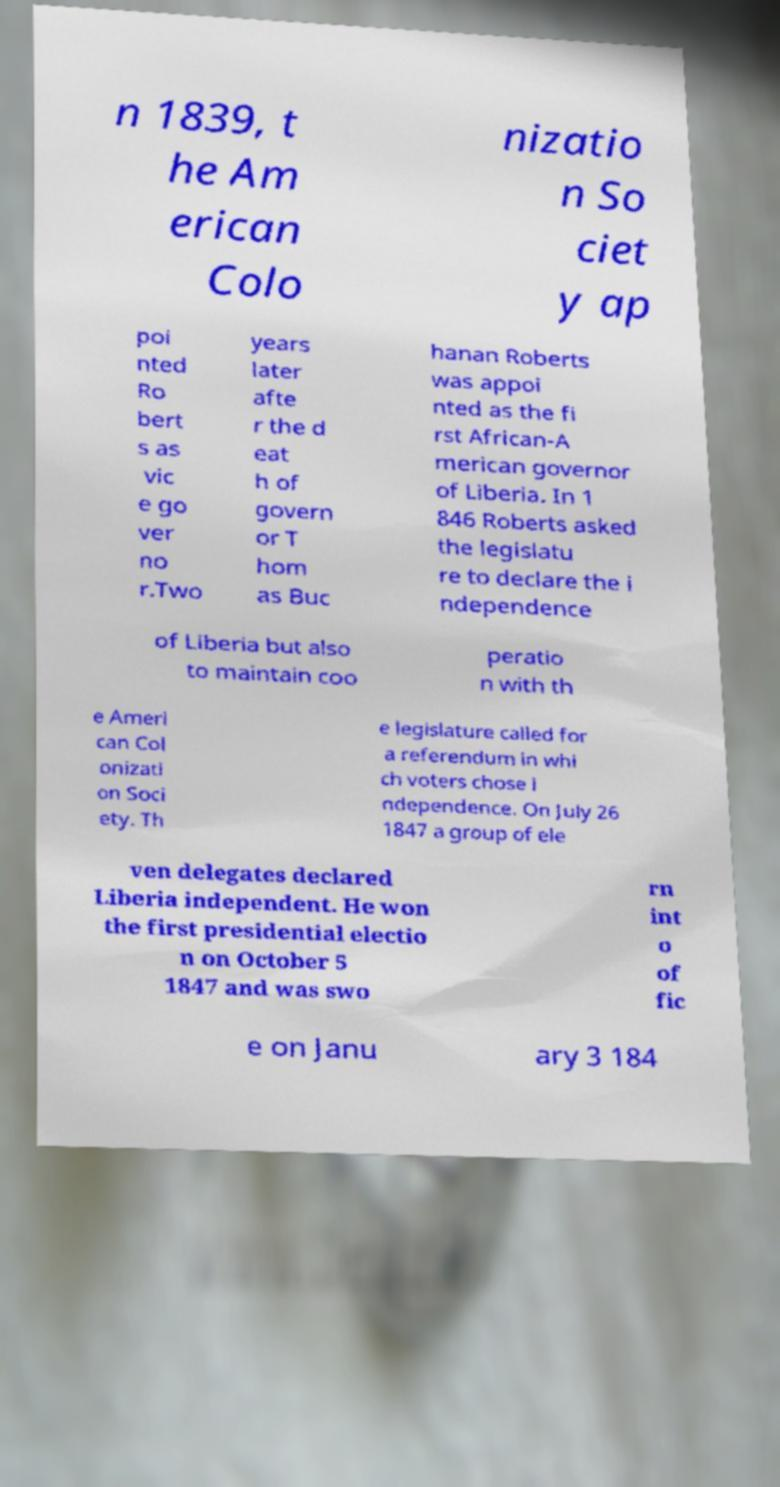What messages or text are displayed in this image? I need them in a readable, typed format. n 1839, t he Am erican Colo nizatio n So ciet y ap poi nted Ro bert s as vic e go ver no r.Two years later afte r the d eat h of govern or T hom as Buc hanan Roberts was appoi nted as the fi rst African-A merican governor of Liberia. In 1 846 Roberts asked the legislatu re to declare the i ndependence of Liberia but also to maintain coo peratio n with th e Ameri can Col onizati on Soci ety. Th e legislature called for a referendum in whi ch voters chose i ndependence. On July 26 1847 a group of ele ven delegates declared Liberia independent. He won the first presidential electio n on October 5 1847 and was swo rn int o of fic e on Janu ary 3 184 